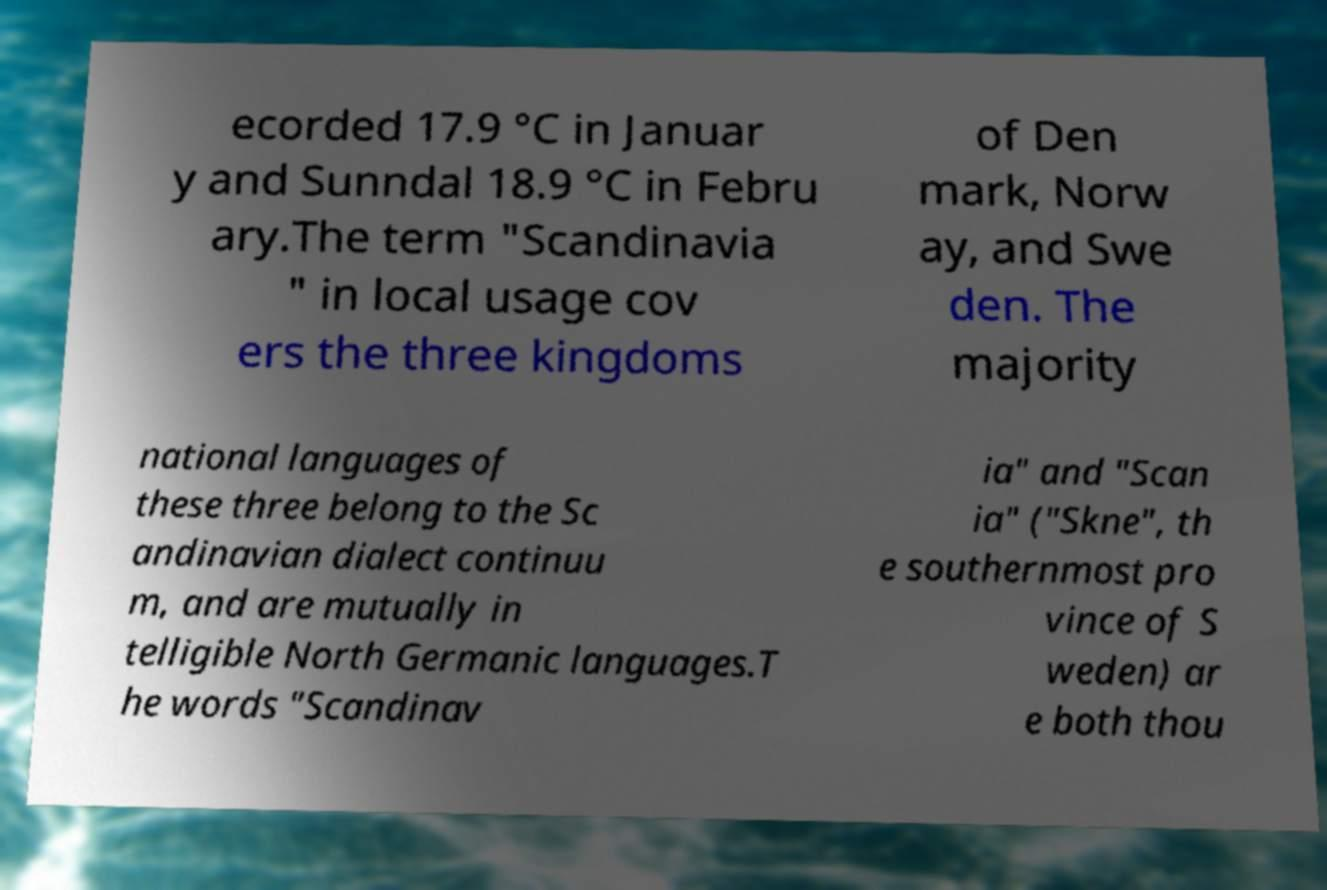What messages or text are displayed in this image? I need them in a readable, typed format. ecorded 17.9 °C in Januar y and Sunndal 18.9 °C in Febru ary.The term "Scandinavia " in local usage cov ers the three kingdoms of Den mark, Norw ay, and Swe den. The majority national languages of these three belong to the Sc andinavian dialect continuu m, and are mutually in telligible North Germanic languages.T he words "Scandinav ia" and "Scan ia" ("Skne", th e southernmost pro vince of S weden) ar e both thou 